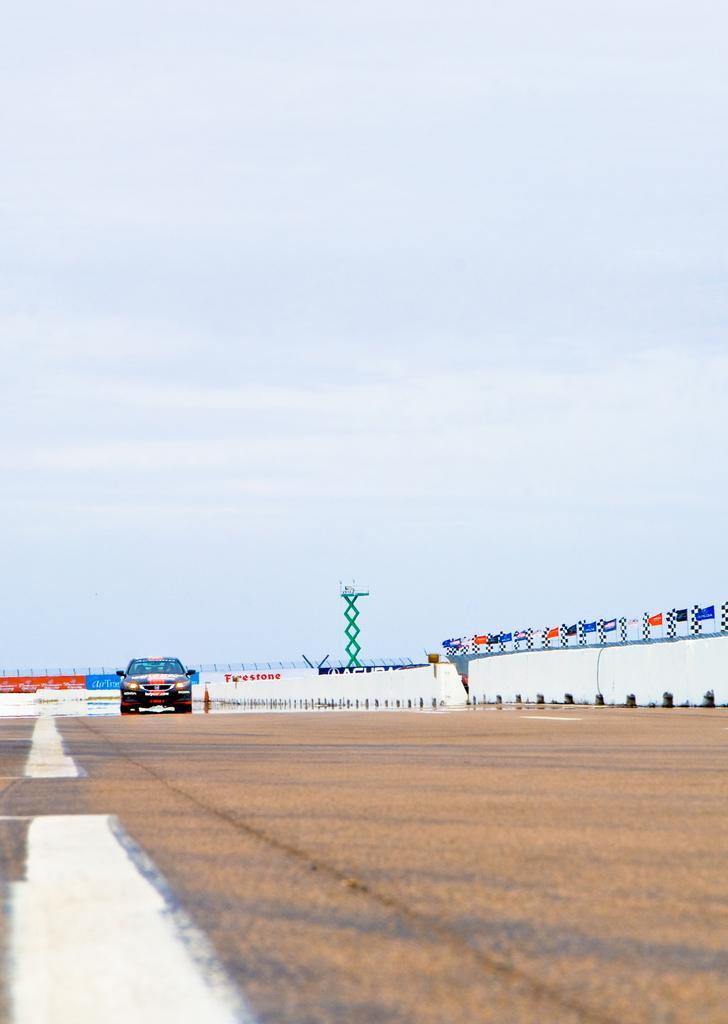Can you describe this image briefly? In this image we can see a vehicle on the road, there are some boards with text on it, also we can see some flags on the wall and there is a tower, in the background we can see the sky. 